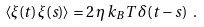<formula> <loc_0><loc_0><loc_500><loc_500>\langle \xi ( t ) \, \xi ( s ) \rangle = 2 \, \eta \, k _ { B } T \, \delta ( t - s ) \ .</formula> 